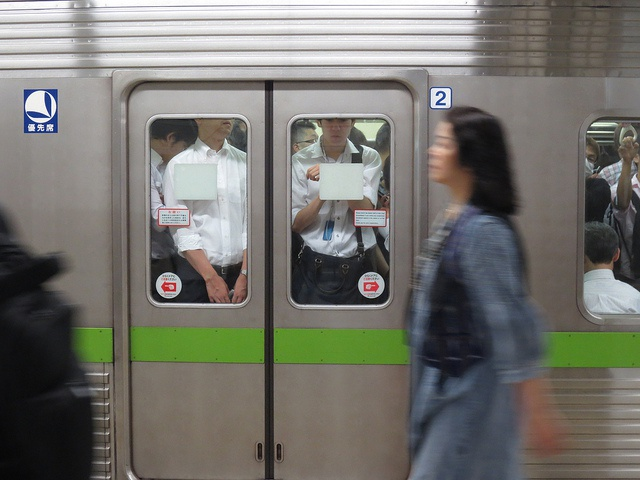Describe the objects in this image and their specific colors. I can see train in gray, darkgray, lightgray, and black tones, people in darkgray, gray, and black tones, people in darkgray, black, gray, and lightgray tones, people in darkgray, lightgray, gray, and black tones, and people in darkgray, black, and gray tones in this image. 